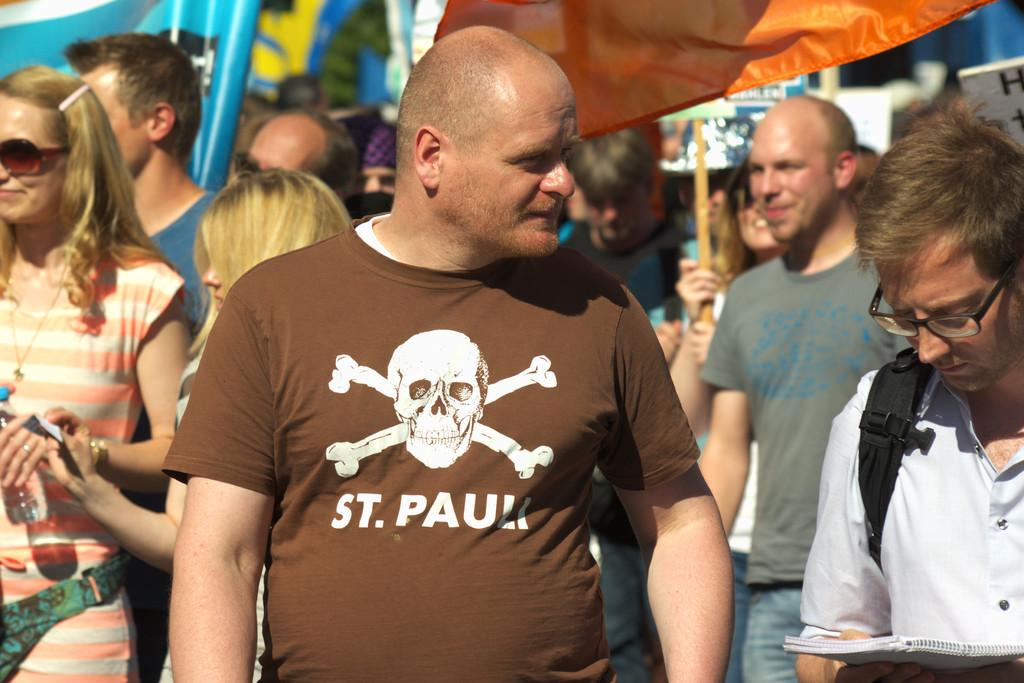How many people are in the image? There is a group of people in the image. What color cloth can be seen in the background? There is an orange color cloth in the background. What object is present in the background, and who is holding it? There is a board in the background, and a person is holding it. What material is the rod associated with the board made of? The rod associated with the board is made of metal. Can you see a cow holding an umbrella in the image? No, there is no cow or umbrella present in the image. 